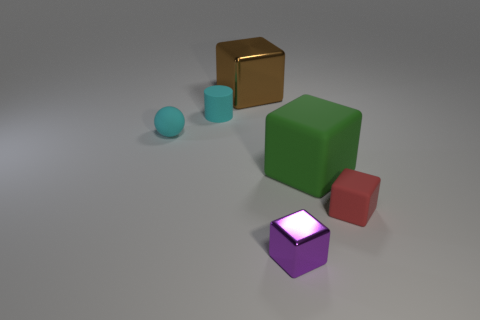Add 3 large green shiny cylinders. How many objects exist? 9 Subtract all cylinders. How many objects are left? 5 Add 5 small metal things. How many small metal things are left? 6 Add 2 cyan balls. How many cyan balls exist? 3 Subtract 0 green cylinders. How many objects are left? 6 Subtract all big green things. Subtract all matte balls. How many objects are left? 4 